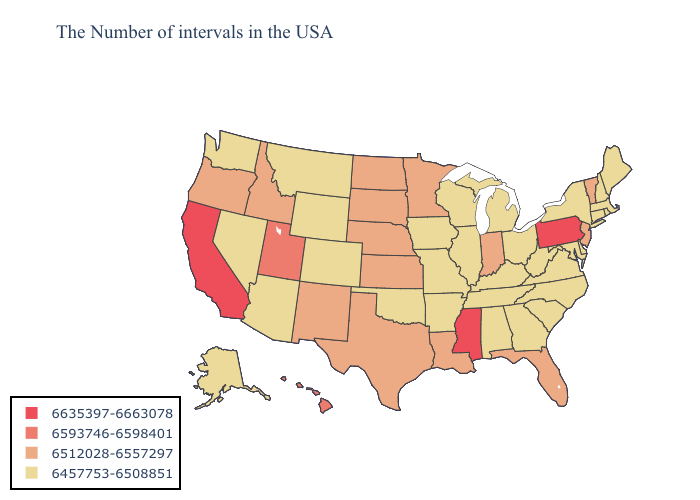Among the states that border Kansas , which have the lowest value?
Be succinct. Missouri, Oklahoma, Colorado. Does the first symbol in the legend represent the smallest category?
Be succinct. No. Does Montana have the highest value in the USA?
Concise answer only. No. Does Nevada have the same value as California?
Give a very brief answer. No. What is the lowest value in the MidWest?
Answer briefly. 6457753-6508851. What is the value of Arizona?
Quick response, please. 6457753-6508851. What is the lowest value in the USA?
Concise answer only. 6457753-6508851. What is the value of Nevada?
Short answer required. 6457753-6508851. Does Wyoming have the same value as Maine?
Be succinct. Yes. Among the states that border Idaho , which have the lowest value?
Concise answer only. Wyoming, Montana, Nevada, Washington. What is the lowest value in the West?
Concise answer only. 6457753-6508851. Does the map have missing data?
Answer briefly. No. What is the value of Pennsylvania?
Be succinct. 6635397-6663078. Which states have the highest value in the USA?
Write a very short answer. Pennsylvania, Mississippi, California. What is the value of Delaware?
Give a very brief answer. 6457753-6508851. 